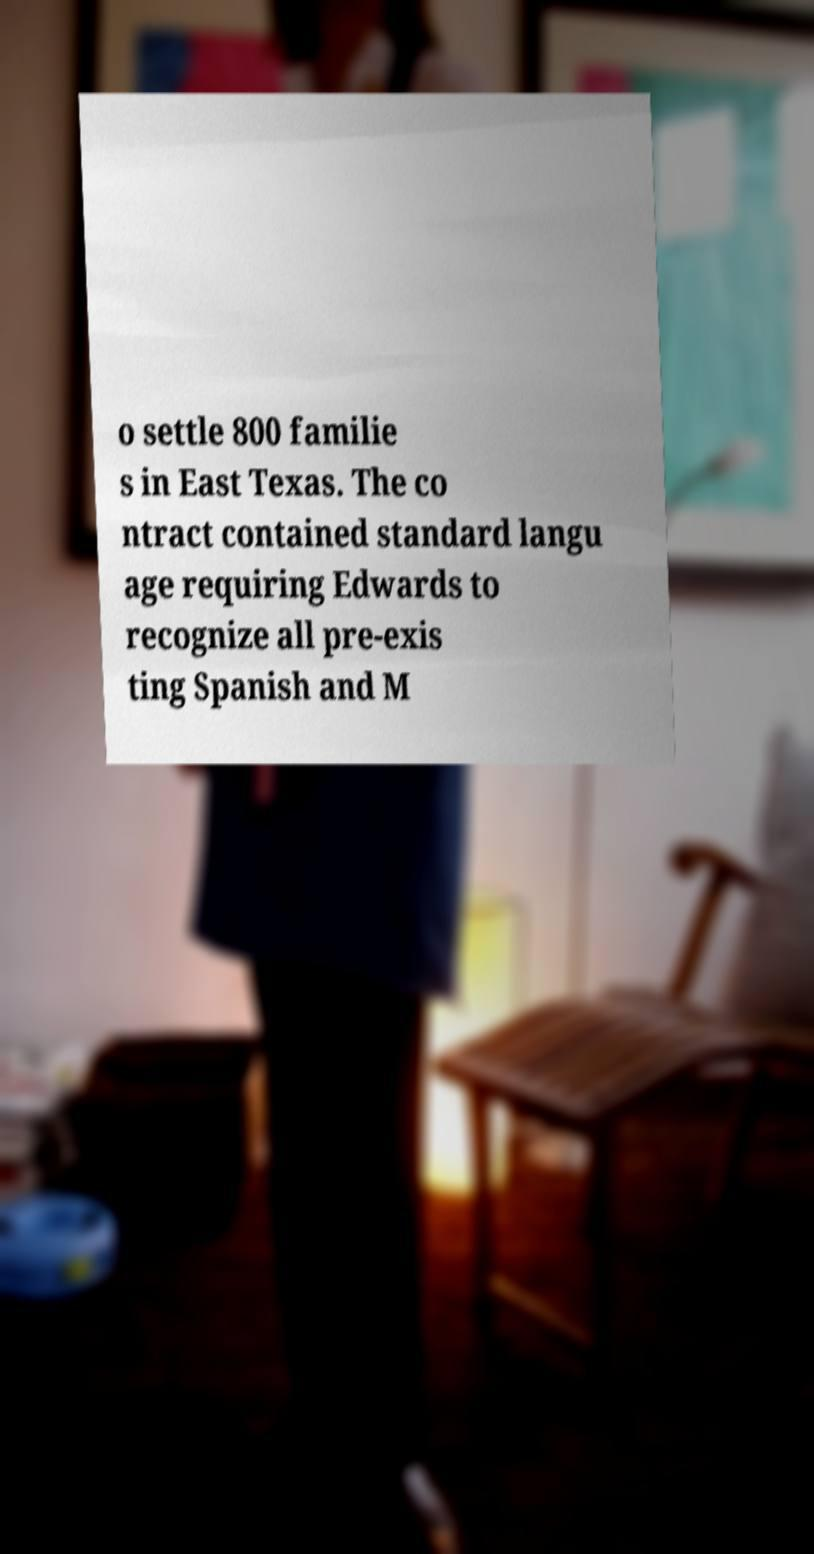I need the written content from this picture converted into text. Can you do that? o settle 800 familie s in East Texas. The co ntract contained standard langu age requiring Edwards to recognize all pre-exis ting Spanish and M 